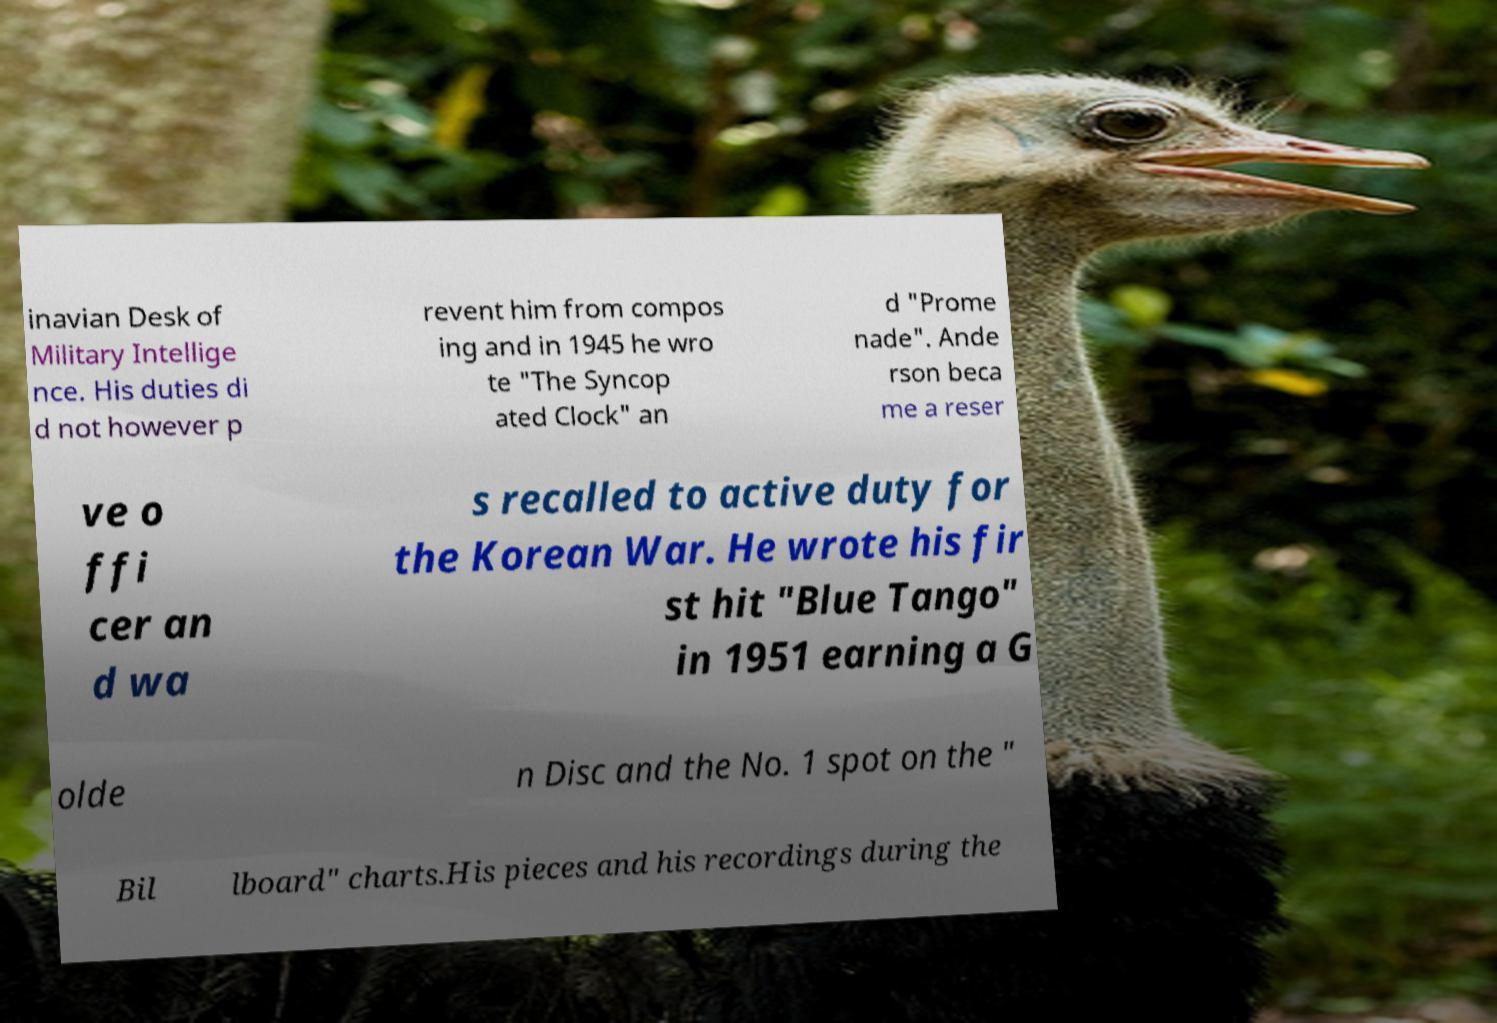For documentation purposes, I need the text within this image transcribed. Could you provide that? inavian Desk of Military Intellige nce. His duties di d not however p revent him from compos ing and in 1945 he wro te "The Syncop ated Clock" an d "Prome nade". Ande rson beca me a reser ve o ffi cer an d wa s recalled to active duty for the Korean War. He wrote his fir st hit "Blue Tango" in 1951 earning a G olde n Disc and the No. 1 spot on the " Bil lboard" charts.His pieces and his recordings during the 